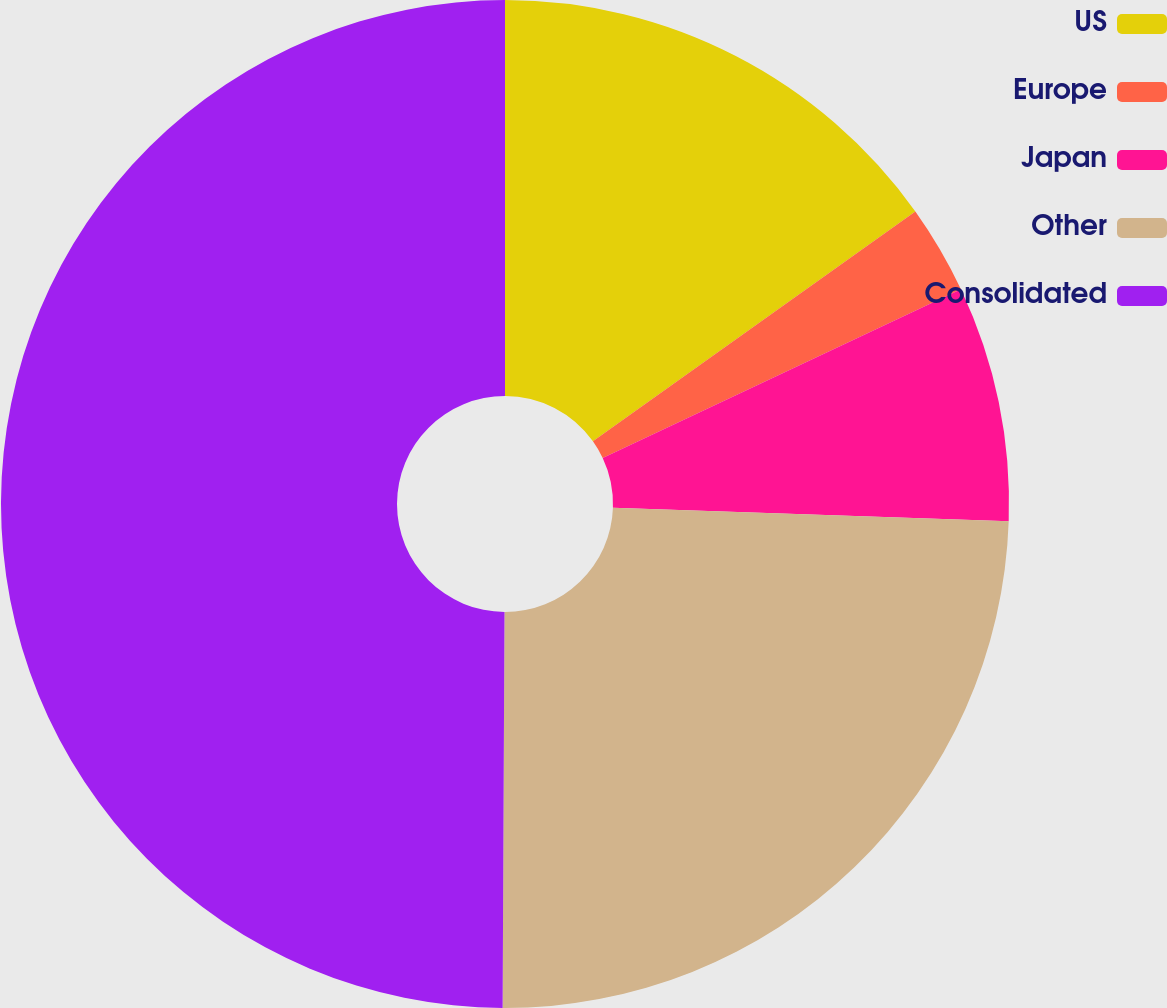Convert chart. <chart><loc_0><loc_0><loc_500><loc_500><pie_chart><fcel>US<fcel>Europe<fcel>Japan<fcel>Other<fcel>Consolidated<nl><fcel>15.14%<fcel>2.85%<fcel>7.55%<fcel>24.53%<fcel>49.92%<nl></chart> 